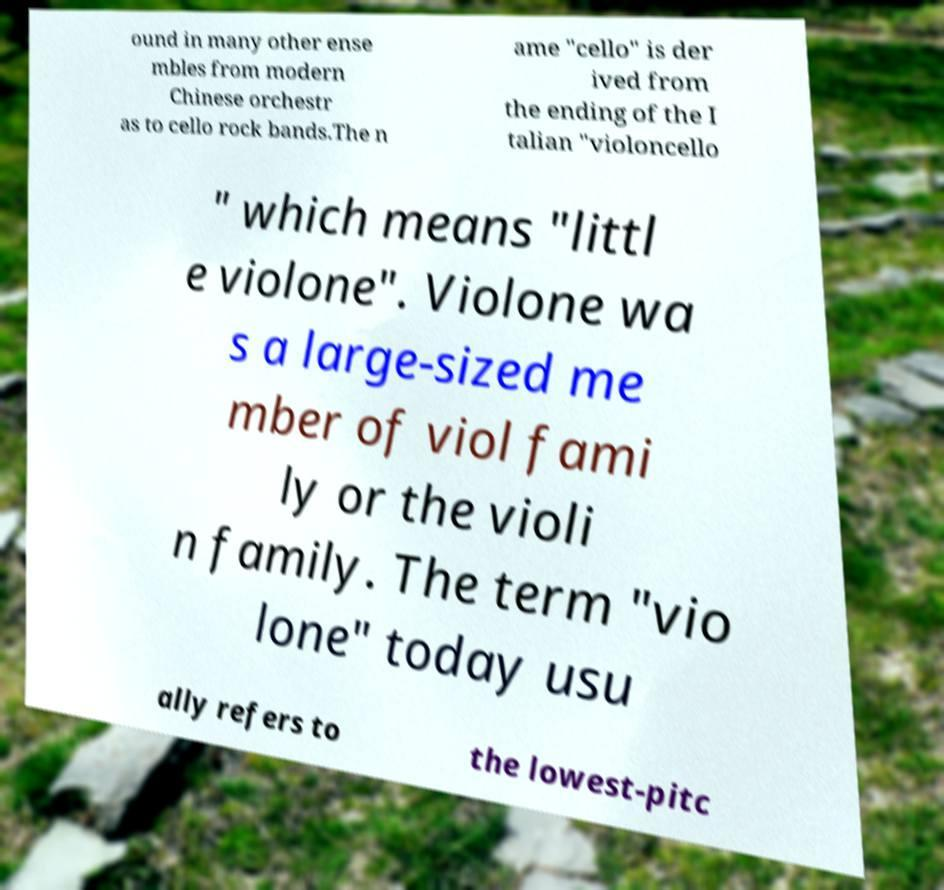There's text embedded in this image that I need extracted. Can you transcribe it verbatim? ound in many other ense mbles from modern Chinese orchestr as to cello rock bands.The n ame "cello" is der ived from the ending of the I talian "violoncello " which means "littl e violone". Violone wa s a large-sized me mber of viol fami ly or the violi n family. The term "vio lone" today usu ally refers to the lowest-pitc 